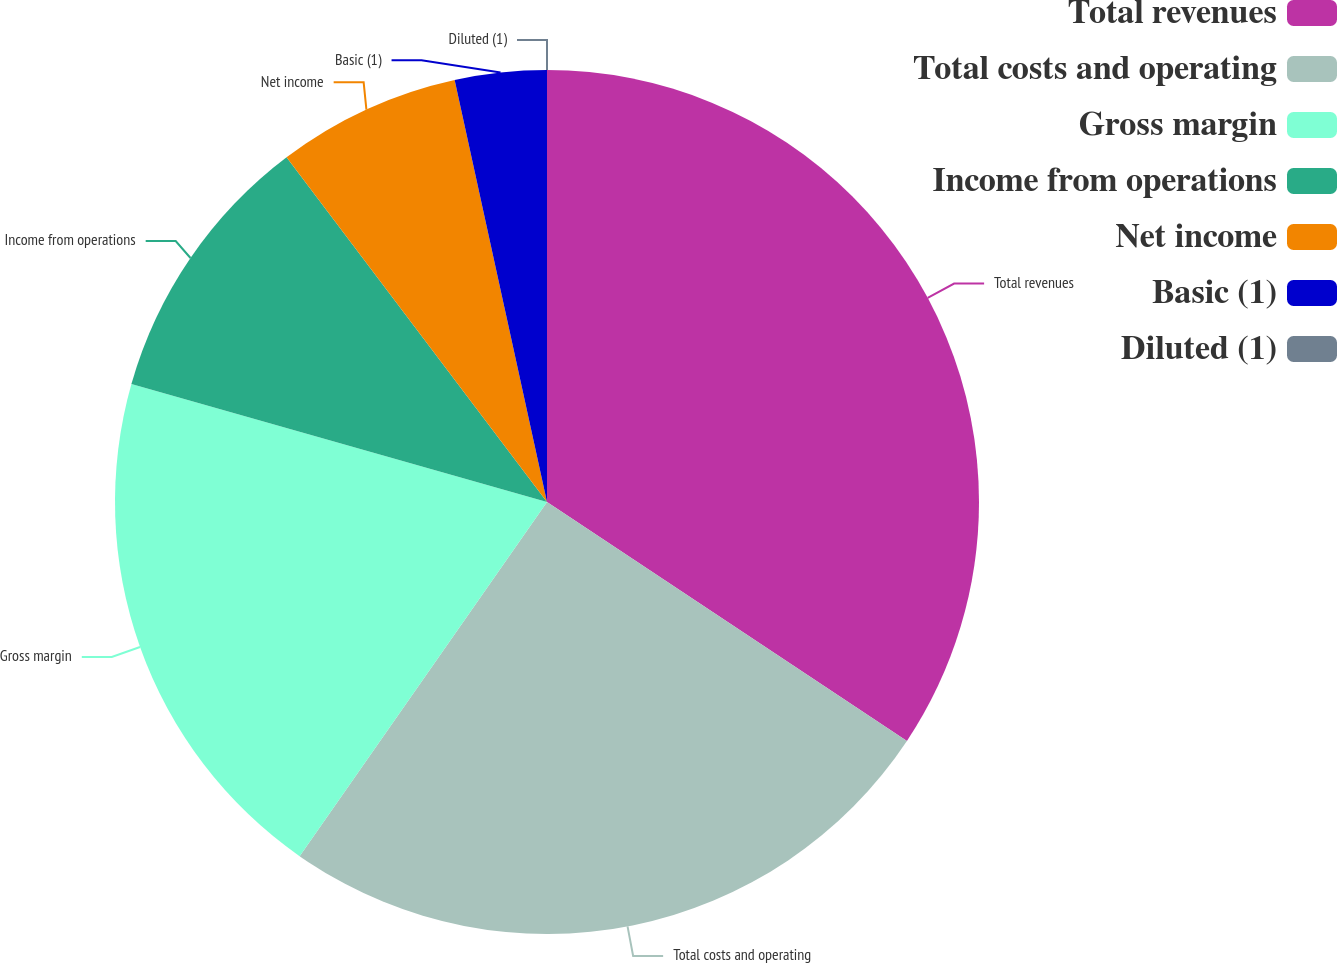Convert chart. <chart><loc_0><loc_0><loc_500><loc_500><pie_chart><fcel>Total revenues<fcel>Total costs and operating<fcel>Gross margin<fcel>Income from operations<fcel>Net income<fcel>Basic (1)<fcel>Diluted (1)<nl><fcel>34.33%<fcel>25.38%<fcel>19.7%<fcel>10.3%<fcel>6.87%<fcel>3.43%<fcel>0.0%<nl></chart> 